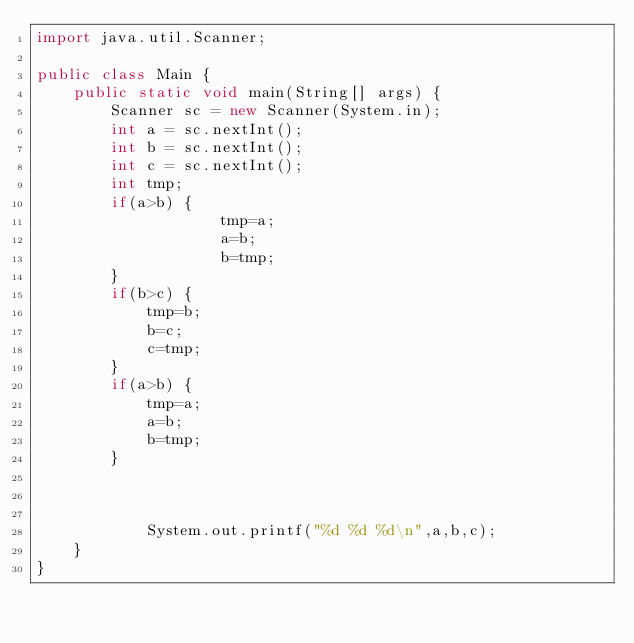<code> <loc_0><loc_0><loc_500><loc_500><_Java_>import java.util.Scanner;

public class Main {
	public static void main(String[] args) {
		Scanner sc = new Scanner(System.in);
		int a = sc.nextInt();
		int b = sc.nextInt();
		int c = sc.nextInt();
		int tmp;
		if(a>b) {
					tmp=a;
					a=b;
					b=tmp;
		}
		if(b>c) {
			tmp=b;
			b=c;
			c=tmp;
		}
		if(a>b) {
			tmp=a;
			a=b;
			b=tmp;
		}



			System.out.printf("%d %d %d\n",a,b,c);
	}
}


</code> 